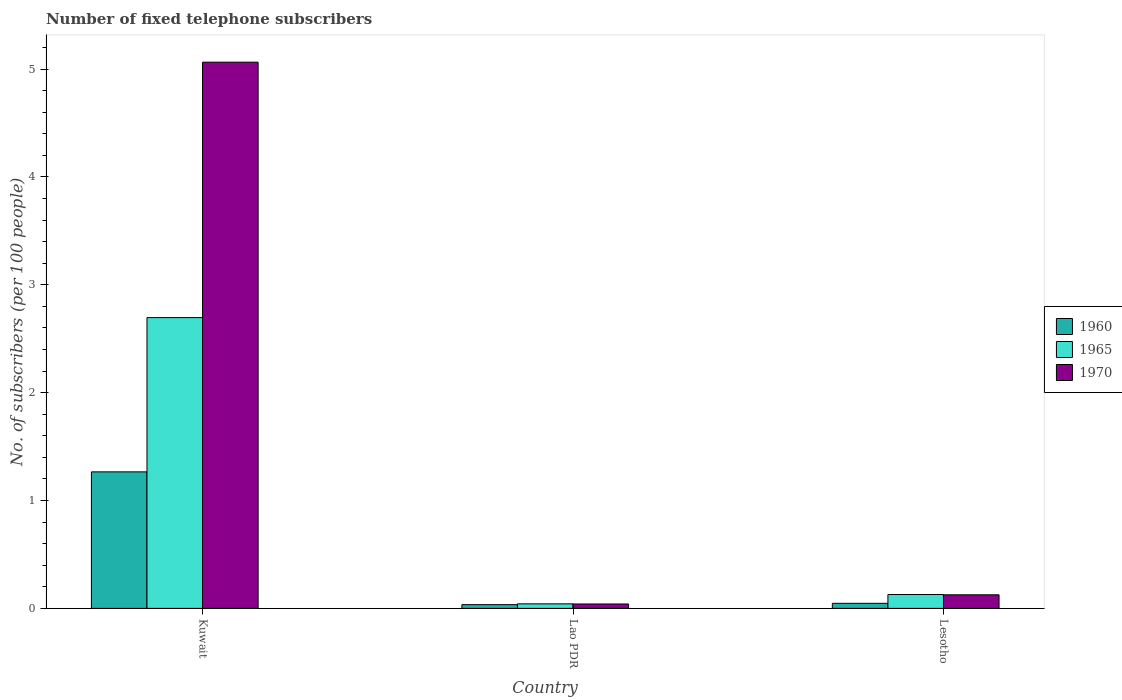How many different coloured bars are there?
Keep it short and to the point. 3. How many groups of bars are there?
Make the answer very short. 3. Are the number of bars per tick equal to the number of legend labels?
Ensure brevity in your answer.  Yes. Are the number of bars on each tick of the X-axis equal?
Offer a terse response. Yes. How many bars are there on the 3rd tick from the left?
Your response must be concise. 3. How many bars are there on the 1st tick from the right?
Offer a terse response. 3. What is the label of the 1st group of bars from the left?
Keep it short and to the point. Kuwait. In how many cases, is the number of bars for a given country not equal to the number of legend labels?
Make the answer very short. 0. What is the number of fixed telephone subscribers in 1965 in Lao PDR?
Your response must be concise. 0.04. Across all countries, what is the maximum number of fixed telephone subscribers in 1960?
Ensure brevity in your answer.  1.27. Across all countries, what is the minimum number of fixed telephone subscribers in 1965?
Offer a terse response. 0.04. In which country was the number of fixed telephone subscribers in 1970 maximum?
Your answer should be compact. Kuwait. In which country was the number of fixed telephone subscribers in 1960 minimum?
Your answer should be compact. Lao PDR. What is the total number of fixed telephone subscribers in 1970 in the graph?
Ensure brevity in your answer.  5.23. What is the difference between the number of fixed telephone subscribers in 1960 in Kuwait and that in Lao PDR?
Your answer should be compact. 1.23. What is the difference between the number of fixed telephone subscribers in 1970 in Kuwait and the number of fixed telephone subscribers in 1960 in Lao PDR?
Your response must be concise. 5.03. What is the average number of fixed telephone subscribers in 1970 per country?
Your response must be concise. 1.74. What is the difference between the number of fixed telephone subscribers of/in 1960 and number of fixed telephone subscribers of/in 1970 in Kuwait?
Your response must be concise. -3.8. What is the ratio of the number of fixed telephone subscribers in 1970 in Kuwait to that in Lesotho?
Keep it short and to the point. 40.21. Is the number of fixed telephone subscribers in 1970 in Kuwait less than that in Lesotho?
Your response must be concise. No. What is the difference between the highest and the second highest number of fixed telephone subscribers in 1965?
Your answer should be very brief. -2.57. What is the difference between the highest and the lowest number of fixed telephone subscribers in 1970?
Make the answer very short. 5.02. In how many countries, is the number of fixed telephone subscribers in 1970 greater than the average number of fixed telephone subscribers in 1970 taken over all countries?
Your response must be concise. 1. What does the 3rd bar from the left in Kuwait represents?
Your answer should be compact. 1970. What does the 1st bar from the right in Lesotho represents?
Provide a short and direct response. 1970. Is it the case that in every country, the sum of the number of fixed telephone subscribers in 1970 and number of fixed telephone subscribers in 1965 is greater than the number of fixed telephone subscribers in 1960?
Your response must be concise. Yes. Are the values on the major ticks of Y-axis written in scientific E-notation?
Give a very brief answer. No. How are the legend labels stacked?
Offer a terse response. Vertical. What is the title of the graph?
Your response must be concise. Number of fixed telephone subscribers. What is the label or title of the X-axis?
Your answer should be compact. Country. What is the label or title of the Y-axis?
Offer a terse response. No. of subscribers (per 100 people). What is the No. of subscribers (per 100 people) of 1960 in Kuwait?
Your answer should be very brief. 1.27. What is the No. of subscribers (per 100 people) in 1965 in Kuwait?
Give a very brief answer. 2.7. What is the No. of subscribers (per 100 people) of 1970 in Kuwait?
Provide a short and direct response. 5.06. What is the No. of subscribers (per 100 people) in 1960 in Lao PDR?
Provide a succinct answer. 0.03. What is the No. of subscribers (per 100 people) in 1965 in Lao PDR?
Your answer should be very brief. 0.04. What is the No. of subscribers (per 100 people) of 1970 in Lao PDR?
Your answer should be compact. 0.04. What is the No. of subscribers (per 100 people) in 1960 in Lesotho?
Make the answer very short. 0.05. What is the No. of subscribers (per 100 people) in 1965 in Lesotho?
Your answer should be compact. 0.13. What is the No. of subscribers (per 100 people) in 1970 in Lesotho?
Ensure brevity in your answer.  0.13. Across all countries, what is the maximum No. of subscribers (per 100 people) of 1960?
Keep it short and to the point. 1.27. Across all countries, what is the maximum No. of subscribers (per 100 people) in 1965?
Provide a short and direct response. 2.7. Across all countries, what is the maximum No. of subscribers (per 100 people) in 1970?
Provide a short and direct response. 5.06. Across all countries, what is the minimum No. of subscribers (per 100 people) in 1960?
Provide a short and direct response. 0.03. Across all countries, what is the minimum No. of subscribers (per 100 people) of 1965?
Ensure brevity in your answer.  0.04. Across all countries, what is the minimum No. of subscribers (per 100 people) of 1970?
Offer a terse response. 0.04. What is the total No. of subscribers (per 100 people) in 1960 in the graph?
Your response must be concise. 1.35. What is the total No. of subscribers (per 100 people) of 1965 in the graph?
Provide a succinct answer. 2.87. What is the total No. of subscribers (per 100 people) in 1970 in the graph?
Your answer should be compact. 5.23. What is the difference between the No. of subscribers (per 100 people) of 1960 in Kuwait and that in Lao PDR?
Make the answer very short. 1.23. What is the difference between the No. of subscribers (per 100 people) of 1965 in Kuwait and that in Lao PDR?
Provide a succinct answer. 2.65. What is the difference between the No. of subscribers (per 100 people) in 1970 in Kuwait and that in Lao PDR?
Your answer should be very brief. 5.02. What is the difference between the No. of subscribers (per 100 people) in 1960 in Kuwait and that in Lesotho?
Your answer should be compact. 1.22. What is the difference between the No. of subscribers (per 100 people) in 1965 in Kuwait and that in Lesotho?
Offer a very short reply. 2.57. What is the difference between the No. of subscribers (per 100 people) in 1970 in Kuwait and that in Lesotho?
Provide a short and direct response. 4.94. What is the difference between the No. of subscribers (per 100 people) of 1960 in Lao PDR and that in Lesotho?
Provide a short and direct response. -0.01. What is the difference between the No. of subscribers (per 100 people) in 1965 in Lao PDR and that in Lesotho?
Provide a short and direct response. -0.09. What is the difference between the No. of subscribers (per 100 people) of 1970 in Lao PDR and that in Lesotho?
Make the answer very short. -0.09. What is the difference between the No. of subscribers (per 100 people) of 1960 in Kuwait and the No. of subscribers (per 100 people) of 1965 in Lao PDR?
Keep it short and to the point. 1.22. What is the difference between the No. of subscribers (per 100 people) in 1960 in Kuwait and the No. of subscribers (per 100 people) in 1970 in Lao PDR?
Offer a very short reply. 1.22. What is the difference between the No. of subscribers (per 100 people) of 1965 in Kuwait and the No. of subscribers (per 100 people) of 1970 in Lao PDR?
Provide a short and direct response. 2.65. What is the difference between the No. of subscribers (per 100 people) of 1960 in Kuwait and the No. of subscribers (per 100 people) of 1965 in Lesotho?
Provide a succinct answer. 1.14. What is the difference between the No. of subscribers (per 100 people) of 1960 in Kuwait and the No. of subscribers (per 100 people) of 1970 in Lesotho?
Give a very brief answer. 1.14. What is the difference between the No. of subscribers (per 100 people) in 1965 in Kuwait and the No. of subscribers (per 100 people) in 1970 in Lesotho?
Provide a succinct answer. 2.57. What is the difference between the No. of subscribers (per 100 people) in 1960 in Lao PDR and the No. of subscribers (per 100 people) in 1965 in Lesotho?
Give a very brief answer. -0.09. What is the difference between the No. of subscribers (per 100 people) of 1960 in Lao PDR and the No. of subscribers (per 100 people) of 1970 in Lesotho?
Provide a succinct answer. -0.09. What is the difference between the No. of subscribers (per 100 people) in 1965 in Lao PDR and the No. of subscribers (per 100 people) in 1970 in Lesotho?
Provide a succinct answer. -0.08. What is the average No. of subscribers (per 100 people) of 1960 per country?
Your response must be concise. 0.45. What is the average No. of subscribers (per 100 people) of 1965 per country?
Ensure brevity in your answer.  0.96. What is the average No. of subscribers (per 100 people) in 1970 per country?
Your response must be concise. 1.74. What is the difference between the No. of subscribers (per 100 people) of 1960 and No. of subscribers (per 100 people) of 1965 in Kuwait?
Provide a succinct answer. -1.43. What is the difference between the No. of subscribers (per 100 people) of 1960 and No. of subscribers (per 100 people) of 1970 in Kuwait?
Your response must be concise. -3.8. What is the difference between the No. of subscribers (per 100 people) in 1965 and No. of subscribers (per 100 people) in 1970 in Kuwait?
Keep it short and to the point. -2.37. What is the difference between the No. of subscribers (per 100 people) in 1960 and No. of subscribers (per 100 people) in 1965 in Lao PDR?
Ensure brevity in your answer.  -0.01. What is the difference between the No. of subscribers (per 100 people) of 1960 and No. of subscribers (per 100 people) of 1970 in Lao PDR?
Your answer should be very brief. -0.01. What is the difference between the No. of subscribers (per 100 people) in 1965 and No. of subscribers (per 100 people) in 1970 in Lao PDR?
Provide a succinct answer. 0. What is the difference between the No. of subscribers (per 100 people) in 1960 and No. of subscribers (per 100 people) in 1965 in Lesotho?
Offer a terse response. -0.08. What is the difference between the No. of subscribers (per 100 people) of 1960 and No. of subscribers (per 100 people) of 1970 in Lesotho?
Your response must be concise. -0.08. What is the difference between the No. of subscribers (per 100 people) of 1965 and No. of subscribers (per 100 people) of 1970 in Lesotho?
Your answer should be very brief. 0. What is the ratio of the No. of subscribers (per 100 people) of 1960 in Kuwait to that in Lao PDR?
Give a very brief answer. 36.45. What is the ratio of the No. of subscribers (per 100 people) of 1965 in Kuwait to that in Lao PDR?
Offer a very short reply. 64.17. What is the ratio of the No. of subscribers (per 100 people) in 1970 in Kuwait to that in Lao PDR?
Offer a terse response. 123.61. What is the ratio of the No. of subscribers (per 100 people) of 1960 in Kuwait to that in Lesotho?
Offer a very short reply. 26.94. What is the ratio of the No. of subscribers (per 100 people) in 1965 in Kuwait to that in Lesotho?
Provide a succinct answer. 20.96. What is the ratio of the No. of subscribers (per 100 people) of 1970 in Kuwait to that in Lesotho?
Keep it short and to the point. 40.21. What is the ratio of the No. of subscribers (per 100 people) in 1960 in Lao PDR to that in Lesotho?
Your answer should be compact. 0.74. What is the ratio of the No. of subscribers (per 100 people) in 1965 in Lao PDR to that in Lesotho?
Offer a very short reply. 0.33. What is the ratio of the No. of subscribers (per 100 people) in 1970 in Lao PDR to that in Lesotho?
Make the answer very short. 0.33. What is the difference between the highest and the second highest No. of subscribers (per 100 people) of 1960?
Provide a succinct answer. 1.22. What is the difference between the highest and the second highest No. of subscribers (per 100 people) in 1965?
Your answer should be very brief. 2.57. What is the difference between the highest and the second highest No. of subscribers (per 100 people) in 1970?
Offer a very short reply. 4.94. What is the difference between the highest and the lowest No. of subscribers (per 100 people) in 1960?
Provide a short and direct response. 1.23. What is the difference between the highest and the lowest No. of subscribers (per 100 people) of 1965?
Your answer should be very brief. 2.65. What is the difference between the highest and the lowest No. of subscribers (per 100 people) of 1970?
Your answer should be compact. 5.02. 